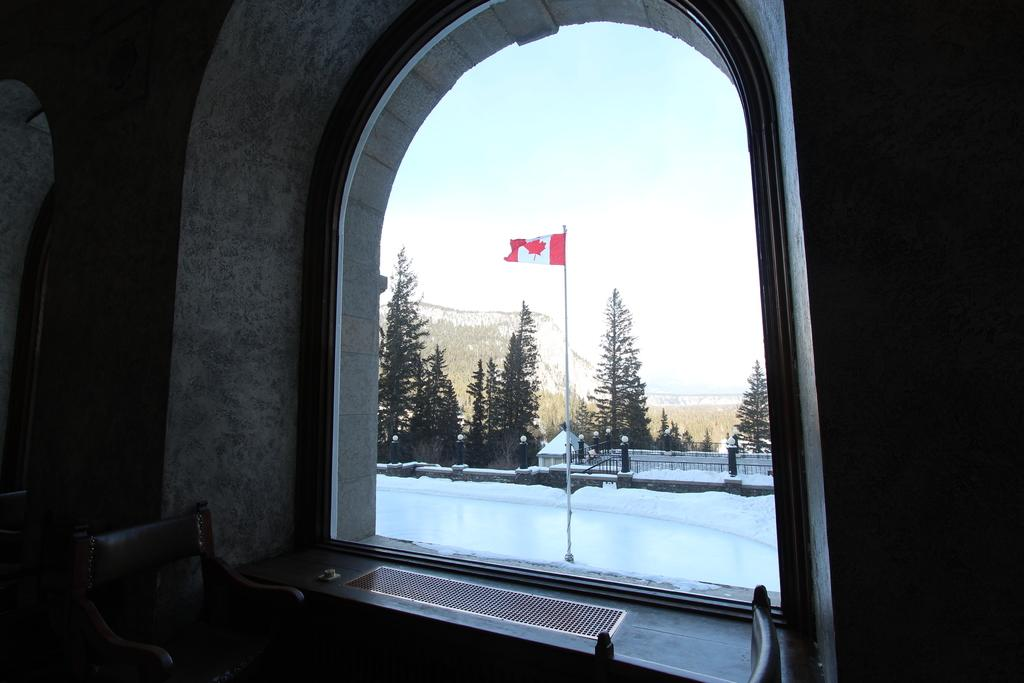What type of furniture can be seen in the image? There are chairs in the image. What natural elements are present in the image? There are trees and mountains in the image. What architectural feature is visible in the image? Railings are visible in the image. What symbol can be seen on a flag post in the image? There is a flag on a flag post in the image. What part of the natural environment is visible in the image? The sky is visible in the image. Where is the frog sitting on the chair in the image? There is no frog present in the image; it only features chairs, trees, railings, a flag on a flag post, mountains, and the sky. What type of meat is being grilled on the railings in the image? There is no meat or grilling activity present in the image. 